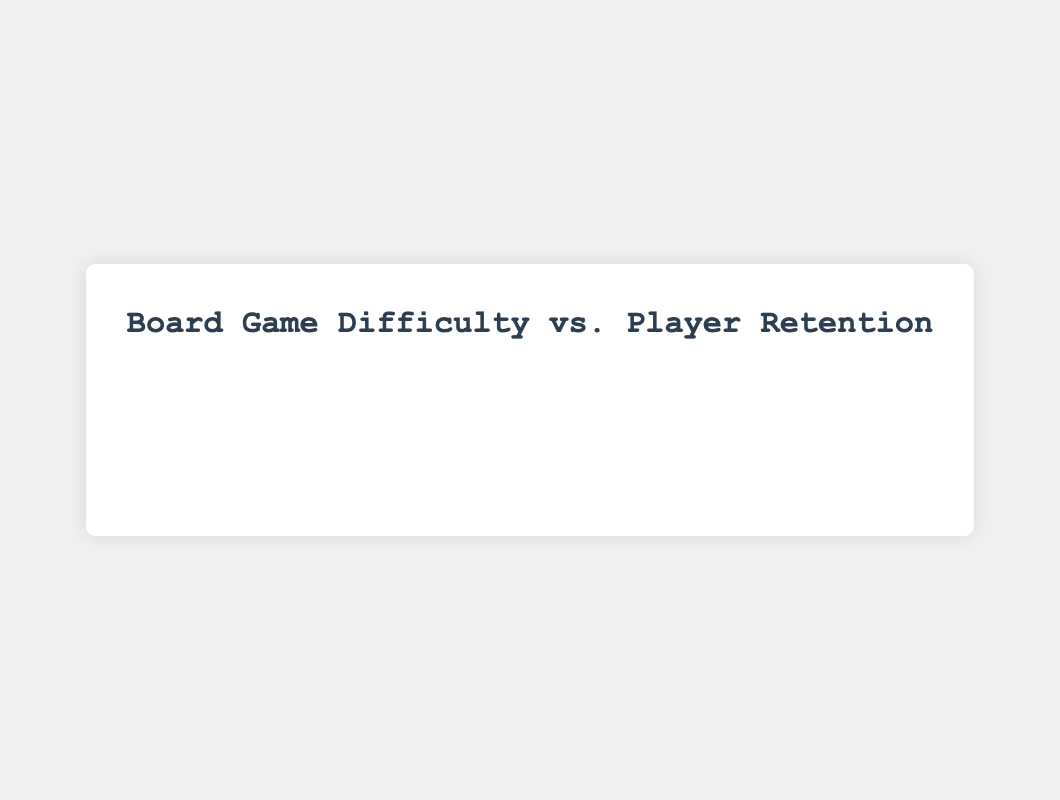What's the player retention rate for "Terraforming Mars" at Medium difficulty? To find the player retention rate for "Terraforming Mars" at Medium difficulty, look for the corresponding bar in the Medium difficulty group for "Terraforming Mars." The given rate is 83%.
Answer: 83% For which game is the difference between Easy and Hard difficulty retention rates the largest? Calculate the difference in retention rates between Easy and Hard difficulties for each game, then compare them. "Gloomhaven" has the biggest difference: 95% - 70% = 25%.
Answer: Gloomhaven Which difficulty level generally has the lowest player retention rate across the games? Compare the lowest retention rate across games for each difficulty level. The Hard difficulty consistently shows the lowest retention rate for every game.
Answer: Hard How does the player retention rate for "Pandemic" at Hard difficulty compare to "Arkham Horror" at Hard difficulty? Look at the bars for Hard difficulty for both "Pandemic" and "Arkham Horror". "Pandemic" has a lower rate (55%) compared to "Arkham Horror" (60%).
Answer: "Pandemic" retention rate is lower What is the average player retention rate for Easy difficulties across all games? Sum the retention rates for Easy difficulty across all games (95 + 92 + 90 + 88 + 93) and divide by the number of games, which is 5. (95 + 92 + 90 + 88 + 93) / 5 = 91.6%.
Answer: 91.6% Which game has the smallest difference in player retention rates between Easy and Hard difficulties? Calculate the difference between Easy and Hard retention rates for each game, then compare them. "Terraforming Mars" has the smallest difference: 92% - 65% = 27%.
Answer: Terraforming Mars Does any game have a higher retention rate for Medium difficulty than an Easy difficulty in another game? Compare the medium retention rates to the minimal easy retention rate (88%). All medium difficulty rates are lower.
Answer: No Which game has the highest retention rate at Easy difficulty level? Identify the highest bar within the Easy difficulty group across all games. "Gloomhaven" has the highest retention rate at 95%.
Answer: Gloomhaven What is the combined retention rate for all difficulty levels for "Catan"? Add the retention rates across all difficulty levels for "Catan" (93 + 82 + 60). 93 + 82 + 60 = 235%.
Answer: 235% How much lower is the retention rate for "Arkham Horror" at Medium difficulty compared to Easy difficulty? Subtract the Medium difficulty retention rate for "Arkham Horror" from the Easy difficulty rate. 90% - 80% = 10%.
Answer: 10% lower 